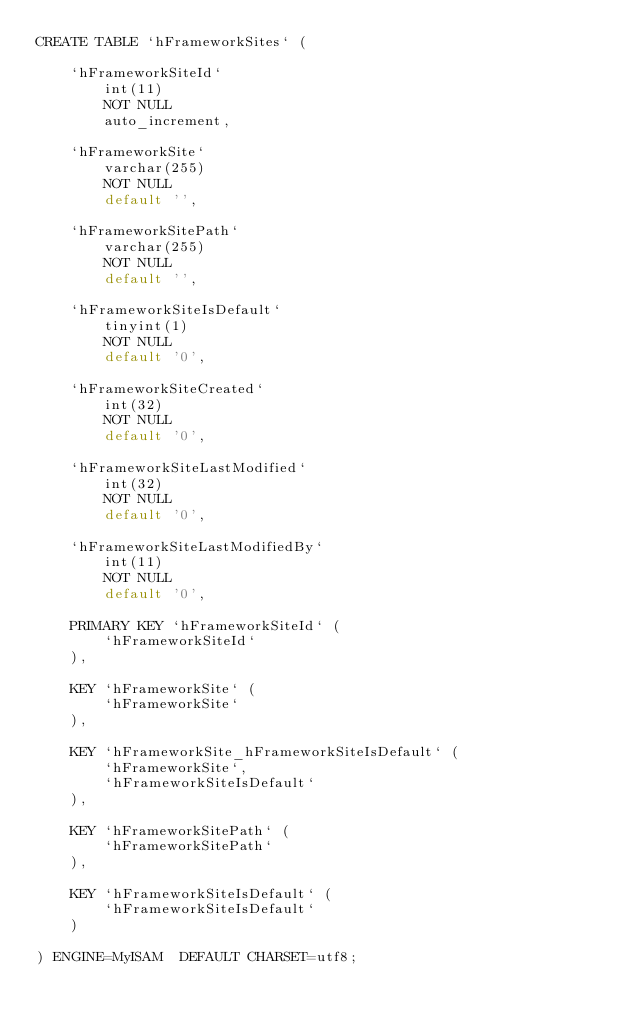Convert code to text. <code><loc_0><loc_0><loc_500><loc_500><_SQL_>CREATE TABLE `hFrameworkSites` (

    `hFrameworkSiteId`
        int(11)
        NOT NULL
        auto_increment,

    `hFrameworkSite`
        varchar(255)
        NOT NULL
        default '',

    `hFrameworkSitePath`
        varchar(255)
        NOT NULL
        default '',

    `hFrameworkSiteIsDefault`
        tinyint(1)
        NOT NULL
        default '0',

    `hFrameworkSiteCreated`
        int(32)
        NOT NULL
        default '0',

    `hFrameworkSiteLastModified`
        int(32)
        NOT NULL
        default '0',

    `hFrameworkSiteLastModifiedBy`
        int(11)
        NOT NULL
        default '0',

    PRIMARY KEY `hFrameworkSiteId` (
        `hFrameworkSiteId`
    ),

    KEY `hFrameworkSite` (
        `hFrameworkSite`
    ),

    KEY `hFrameworkSite_hFrameworkSiteIsDefault` (
        `hFrameworkSite`,
        `hFrameworkSiteIsDefault`
    ),

    KEY `hFrameworkSitePath` (
        `hFrameworkSitePath`
    ),

    KEY `hFrameworkSiteIsDefault` (
        `hFrameworkSiteIsDefault`
    )

) ENGINE=MyISAM  DEFAULT CHARSET=utf8;
</code> 